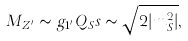<formula> <loc_0><loc_0><loc_500><loc_500>M _ { Z ^ { \prime } } \sim g _ { 1 ^ { \prime } } Q _ { S } s \sim \sqrt { 2 | m _ { S } ^ { 2 } | } ,</formula> 